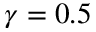<formula> <loc_0><loc_0><loc_500><loc_500>\gamma = 0 . 5</formula> 